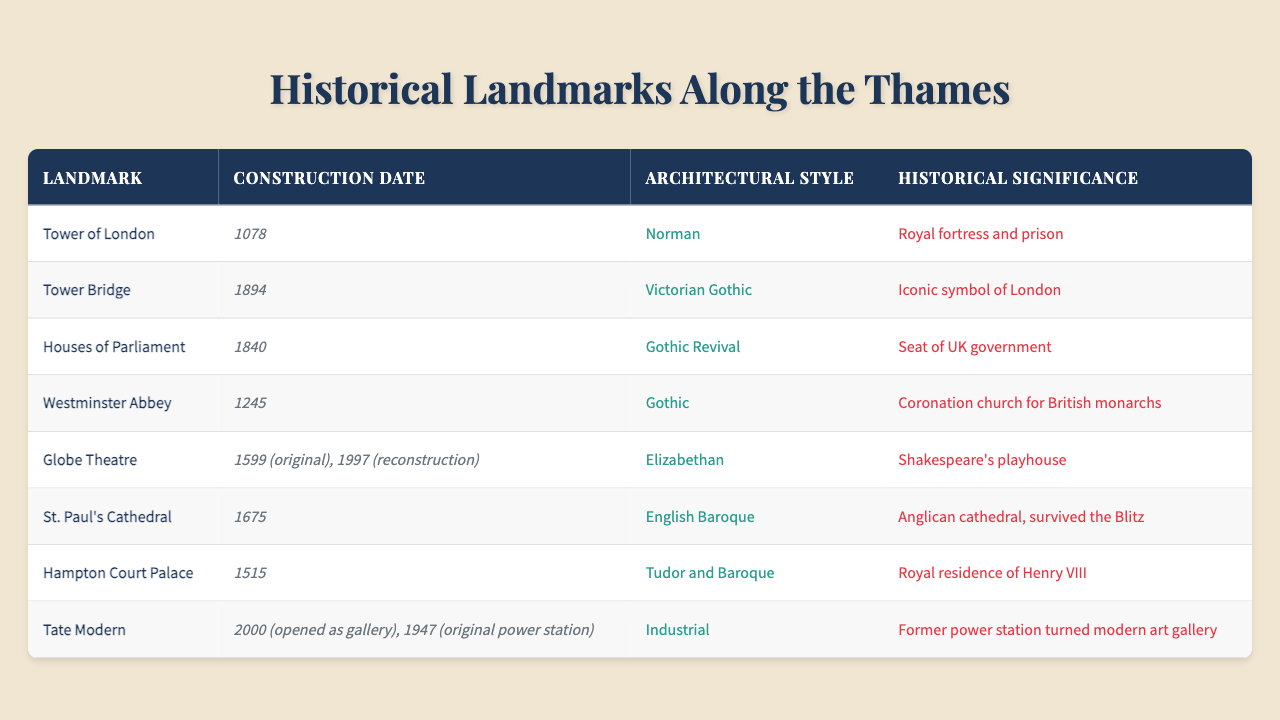What is the construction date of St. Paul's Cathedral? The table lists St. Paul's Cathedral, and its construction date is provided in the corresponding column which states "1675."
Answer: 1675 Which architectural style is associated with the Houses of Parliament? Looking at the row for the Houses of Parliament, the architectural style column indicates "Gothic Revival."
Answer: Gothic Revival Is the Tower of London older than Westminster Abbey? The construction date for the Tower of London is listed as "1078," while Westminster Abbey's is "1245." Since 1078 is earlier than 1245, the statement is true.
Answer: Yes What is the historical significance of the Globe Theatre? The table states that the Globe Theatre was Shakespeare's playhouse, which is mentioned in the historical significance column for that landmark.
Answer: Shakespeare's playhouse Which of the landmarks was constructed in the 19th century? By examining the construction dates, the Houses of Parliament (1840) and Tower Bridge (1894) are both in the 19th century.
Answer: Houses of Parliament, Tower Bridge What is the difference in construction dates between Hampton Court Palace and the Tower Bridge? The construction date for Hampton Court Palace is 1515, and for Tower Bridge, it is 1894. The difference is 1894 - 1515 = 379 years.
Answer: 379 years How many landmarks were constructed in the 17th century? From the table, St. Paul's Cathedral was constructed in 1675, and the Globe Theatre’s original construction was in 1599. So, there are two landmarks from the 17th century.
Answer: 2 landmarks Which landmark has a historical significance related to a royal fortress? The Tower of London is noted for being a royal fortress and prison, as per the historical significance provided in the table.
Answer: Tower of London Are there any landmarks that have been reconstructed? The Globe Theatre shows "1599 (original), 1997 (reconstruction)" in the construction date column, indicating it has undergone a reconstruction.
Answer: Yes What is the architectural style of the Tate Modern? The architectural style for the Tate Modern is listed as "Industrial" in the table.
Answer: Industrial Identify the landmark that symbolizes London and its construction date. Tower Bridge is mentioned as the "Iconic symbol of London" and its construction date is "1894."
Answer: Tower Bridge, 1894 